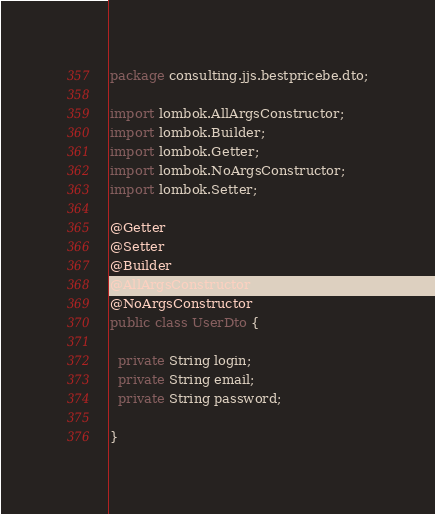Convert code to text. <code><loc_0><loc_0><loc_500><loc_500><_Java_>package consulting.jjs.bestpricebe.dto;

import lombok.AllArgsConstructor;
import lombok.Builder;
import lombok.Getter;
import lombok.NoArgsConstructor;
import lombok.Setter;

@Getter
@Setter
@Builder
@AllArgsConstructor
@NoArgsConstructor
public class UserDto {

  private String login;
  private String email;
  private String password;

}
</code> 